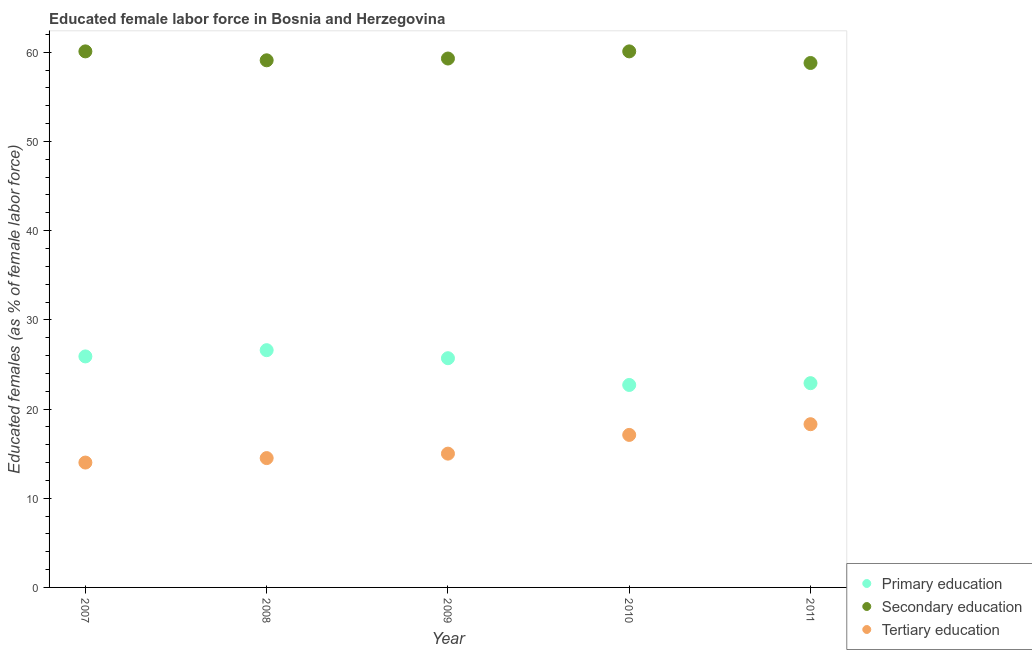What is the percentage of female labor force who received secondary education in 2007?
Provide a short and direct response. 60.1. Across all years, what is the maximum percentage of female labor force who received primary education?
Provide a short and direct response. 26.6. Across all years, what is the minimum percentage of female labor force who received primary education?
Provide a short and direct response. 22.7. In which year was the percentage of female labor force who received secondary education maximum?
Keep it short and to the point. 2007. In which year was the percentage of female labor force who received tertiary education minimum?
Ensure brevity in your answer.  2007. What is the total percentage of female labor force who received tertiary education in the graph?
Ensure brevity in your answer.  78.9. What is the difference between the percentage of female labor force who received secondary education in 2008 and that in 2009?
Your response must be concise. -0.2. What is the difference between the percentage of female labor force who received secondary education in 2010 and the percentage of female labor force who received primary education in 2009?
Give a very brief answer. 34.4. What is the average percentage of female labor force who received secondary education per year?
Offer a very short reply. 59.48. In the year 2007, what is the difference between the percentage of female labor force who received primary education and percentage of female labor force who received tertiary education?
Keep it short and to the point. 11.9. In how many years, is the percentage of female labor force who received primary education greater than 12 %?
Ensure brevity in your answer.  5. What is the ratio of the percentage of female labor force who received secondary education in 2007 to that in 2009?
Offer a very short reply. 1.01. Is the percentage of female labor force who received tertiary education in 2007 less than that in 2009?
Keep it short and to the point. Yes. Is the difference between the percentage of female labor force who received primary education in 2010 and 2011 greater than the difference between the percentage of female labor force who received tertiary education in 2010 and 2011?
Offer a very short reply. Yes. What is the difference between the highest and the second highest percentage of female labor force who received primary education?
Ensure brevity in your answer.  0.7. What is the difference between the highest and the lowest percentage of female labor force who received secondary education?
Offer a terse response. 1.3. In how many years, is the percentage of female labor force who received primary education greater than the average percentage of female labor force who received primary education taken over all years?
Offer a very short reply. 3. Is it the case that in every year, the sum of the percentage of female labor force who received primary education and percentage of female labor force who received secondary education is greater than the percentage of female labor force who received tertiary education?
Provide a short and direct response. Yes. Is the percentage of female labor force who received tertiary education strictly less than the percentage of female labor force who received primary education over the years?
Your answer should be compact. Yes. How many dotlines are there?
Provide a succinct answer. 3. Are the values on the major ticks of Y-axis written in scientific E-notation?
Your response must be concise. No. Does the graph contain grids?
Your answer should be very brief. No. Where does the legend appear in the graph?
Ensure brevity in your answer.  Bottom right. What is the title of the graph?
Your answer should be very brief. Educated female labor force in Bosnia and Herzegovina. What is the label or title of the X-axis?
Your answer should be compact. Year. What is the label or title of the Y-axis?
Make the answer very short. Educated females (as % of female labor force). What is the Educated females (as % of female labor force) of Primary education in 2007?
Provide a succinct answer. 25.9. What is the Educated females (as % of female labor force) in Secondary education in 2007?
Your response must be concise. 60.1. What is the Educated females (as % of female labor force) in Primary education in 2008?
Your response must be concise. 26.6. What is the Educated females (as % of female labor force) of Secondary education in 2008?
Your answer should be very brief. 59.1. What is the Educated females (as % of female labor force) in Tertiary education in 2008?
Provide a short and direct response. 14.5. What is the Educated females (as % of female labor force) of Primary education in 2009?
Provide a succinct answer. 25.7. What is the Educated females (as % of female labor force) in Secondary education in 2009?
Your answer should be compact. 59.3. What is the Educated females (as % of female labor force) of Tertiary education in 2009?
Provide a succinct answer. 15. What is the Educated females (as % of female labor force) of Primary education in 2010?
Your answer should be compact. 22.7. What is the Educated females (as % of female labor force) in Secondary education in 2010?
Offer a very short reply. 60.1. What is the Educated females (as % of female labor force) in Tertiary education in 2010?
Offer a very short reply. 17.1. What is the Educated females (as % of female labor force) in Primary education in 2011?
Your answer should be very brief. 22.9. What is the Educated females (as % of female labor force) of Secondary education in 2011?
Make the answer very short. 58.8. What is the Educated females (as % of female labor force) in Tertiary education in 2011?
Your response must be concise. 18.3. Across all years, what is the maximum Educated females (as % of female labor force) in Primary education?
Offer a terse response. 26.6. Across all years, what is the maximum Educated females (as % of female labor force) in Secondary education?
Your response must be concise. 60.1. Across all years, what is the maximum Educated females (as % of female labor force) of Tertiary education?
Give a very brief answer. 18.3. Across all years, what is the minimum Educated females (as % of female labor force) in Primary education?
Keep it short and to the point. 22.7. Across all years, what is the minimum Educated females (as % of female labor force) of Secondary education?
Provide a short and direct response. 58.8. Across all years, what is the minimum Educated females (as % of female labor force) of Tertiary education?
Your answer should be very brief. 14. What is the total Educated females (as % of female labor force) of Primary education in the graph?
Your answer should be compact. 123.8. What is the total Educated females (as % of female labor force) of Secondary education in the graph?
Give a very brief answer. 297.4. What is the total Educated females (as % of female labor force) of Tertiary education in the graph?
Provide a short and direct response. 78.9. What is the difference between the Educated females (as % of female labor force) in Secondary education in 2007 and that in 2008?
Offer a terse response. 1. What is the difference between the Educated females (as % of female labor force) of Primary education in 2007 and that in 2009?
Make the answer very short. 0.2. What is the difference between the Educated females (as % of female labor force) in Primary education in 2007 and that in 2010?
Give a very brief answer. 3.2. What is the difference between the Educated females (as % of female labor force) in Secondary education in 2007 and that in 2010?
Give a very brief answer. 0. What is the difference between the Educated females (as % of female labor force) of Tertiary education in 2007 and that in 2011?
Your response must be concise. -4.3. What is the difference between the Educated females (as % of female labor force) in Tertiary education in 2008 and that in 2009?
Offer a very short reply. -0.5. What is the difference between the Educated females (as % of female labor force) of Secondary education in 2008 and that in 2010?
Ensure brevity in your answer.  -1. What is the difference between the Educated females (as % of female labor force) in Primary education in 2009 and that in 2010?
Keep it short and to the point. 3. What is the difference between the Educated females (as % of female labor force) of Secondary education in 2009 and that in 2010?
Make the answer very short. -0.8. What is the difference between the Educated females (as % of female labor force) in Primary education in 2009 and that in 2011?
Your response must be concise. 2.8. What is the difference between the Educated females (as % of female labor force) of Secondary education in 2009 and that in 2011?
Offer a very short reply. 0.5. What is the difference between the Educated females (as % of female labor force) in Primary education in 2007 and the Educated females (as % of female labor force) in Secondary education in 2008?
Your response must be concise. -33.2. What is the difference between the Educated females (as % of female labor force) in Primary education in 2007 and the Educated females (as % of female labor force) in Tertiary education in 2008?
Your answer should be very brief. 11.4. What is the difference between the Educated females (as % of female labor force) in Secondary education in 2007 and the Educated females (as % of female labor force) in Tertiary education in 2008?
Offer a very short reply. 45.6. What is the difference between the Educated females (as % of female labor force) in Primary education in 2007 and the Educated females (as % of female labor force) in Secondary education in 2009?
Your answer should be very brief. -33.4. What is the difference between the Educated females (as % of female labor force) in Secondary education in 2007 and the Educated females (as % of female labor force) in Tertiary education in 2009?
Offer a terse response. 45.1. What is the difference between the Educated females (as % of female labor force) of Primary education in 2007 and the Educated females (as % of female labor force) of Secondary education in 2010?
Offer a very short reply. -34.2. What is the difference between the Educated females (as % of female labor force) of Primary education in 2007 and the Educated females (as % of female labor force) of Tertiary education in 2010?
Give a very brief answer. 8.8. What is the difference between the Educated females (as % of female labor force) of Secondary education in 2007 and the Educated females (as % of female labor force) of Tertiary education in 2010?
Give a very brief answer. 43. What is the difference between the Educated females (as % of female labor force) of Primary education in 2007 and the Educated females (as % of female labor force) of Secondary education in 2011?
Ensure brevity in your answer.  -32.9. What is the difference between the Educated females (as % of female labor force) of Primary education in 2007 and the Educated females (as % of female labor force) of Tertiary education in 2011?
Offer a very short reply. 7.6. What is the difference between the Educated females (as % of female labor force) in Secondary education in 2007 and the Educated females (as % of female labor force) in Tertiary education in 2011?
Your response must be concise. 41.8. What is the difference between the Educated females (as % of female labor force) of Primary education in 2008 and the Educated females (as % of female labor force) of Secondary education in 2009?
Keep it short and to the point. -32.7. What is the difference between the Educated females (as % of female labor force) of Secondary education in 2008 and the Educated females (as % of female labor force) of Tertiary education in 2009?
Your answer should be compact. 44.1. What is the difference between the Educated females (as % of female labor force) of Primary education in 2008 and the Educated females (as % of female labor force) of Secondary education in 2010?
Offer a very short reply. -33.5. What is the difference between the Educated females (as % of female labor force) of Primary education in 2008 and the Educated females (as % of female labor force) of Secondary education in 2011?
Offer a terse response. -32.2. What is the difference between the Educated females (as % of female labor force) of Secondary education in 2008 and the Educated females (as % of female labor force) of Tertiary education in 2011?
Make the answer very short. 40.8. What is the difference between the Educated females (as % of female labor force) in Primary education in 2009 and the Educated females (as % of female labor force) in Secondary education in 2010?
Ensure brevity in your answer.  -34.4. What is the difference between the Educated females (as % of female labor force) of Secondary education in 2009 and the Educated females (as % of female labor force) of Tertiary education in 2010?
Your response must be concise. 42.2. What is the difference between the Educated females (as % of female labor force) of Primary education in 2009 and the Educated females (as % of female labor force) of Secondary education in 2011?
Keep it short and to the point. -33.1. What is the difference between the Educated females (as % of female labor force) in Primary education in 2009 and the Educated females (as % of female labor force) in Tertiary education in 2011?
Ensure brevity in your answer.  7.4. What is the difference between the Educated females (as % of female labor force) of Secondary education in 2009 and the Educated females (as % of female labor force) of Tertiary education in 2011?
Give a very brief answer. 41. What is the difference between the Educated females (as % of female labor force) in Primary education in 2010 and the Educated females (as % of female labor force) in Secondary education in 2011?
Your response must be concise. -36.1. What is the difference between the Educated females (as % of female labor force) of Primary education in 2010 and the Educated females (as % of female labor force) of Tertiary education in 2011?
Make the answer very short. 4.4. What is the difference between the Educated females (as % of female labor force) in Secondary education in 2010 and the Educated females (as % of female labor force) in Tertiary education in 2011?
Make the answer very short. 41.8. What is the average Educated females (as % of female labor force) of Primary education per year?
Give a very brief answer. 24.76. What is the average Educated females (as % of female labor force) in Secondary education per year?
Offer a terse response. 59.48. What is the average Educated females (as % of female labor force) of Tertiary education per year?
Your response must be concise. 15.78. In the year 2007, what is the difference between the Educated females (as % of female labor force) of Primary education and Educated females (as % of female labor force) of Secondary education?
Make the answer very short. -34.2. In the year 2007, what is the difference between the Educated females (as % of female labor force) in Secondary education and Educated females (as % of female labor force) in Tertiary education?
Your answer should be compact. 46.1. In the year 2008, what is the difference between the Educated females (as % of female labor force) of Primary education and Educated females (as % of female labor force) of Secondary education?
Ensure brevity in your answer.  -32.5. In the year 2008, what is the difference between the Educated females (as % of female labor force) of Secondary education and Educated females (as % of female labor force) of Tertiary education?
Your response must be concise. 44.6. In the year 2009, what is the difference between the Educated females (as % of female labor force) of Primary education and Educated females (as % of female labor force) of Secondary education?
Your answer should be compact. -33.6. In the year 2009, what is the difference between the Educated females (as % of female labor force) of Primary education and Educated females (as % of female labor force) of Tertiary education?
Your answer should be compact. 10.7. In the year 2009, what is the difference between the Educated females (as % of female labor force) in Secondary education and Educated females (as % of female labor force) in Tertiary education?
Ensure brevity in your answer.  44.3. In the year 2010, what is the difference between the Educated females (as % of female labor force) of Primary education and Educated females (as % of female labor force) of Secondary education?
Provide a short and direct response. -37.4. In the year 2010, what is the difference between the Educated females (as % of female labor force) of Primary education and Educated females (as % of female labor force) of Tertiary education?
Your answer should be compact. 5.6. In the year 2010, what is the difference between the Educated females (as % of female labor force) of Secondary education and Educated females (as % of female labor force) of Tertiary education?
Offer a very short reply. 43. In the year 2011, what is the difference between the Educated females (as % of female labor force) of Primary education and Educated females (as % of female labor force) of Secondary education?
Your answer should be compact. -35.9. In the year 2011, what is the difference between the Educated females (as % of female labor force) in Primary education and Educated females (as % of female labor force) in Tertiary education?
Give a very brief answer. 4.6. In the year 2011, what is the difference between the Educated females (as % of female labor force) of Secondary education and Educated females (as % of female labor force) of Tertiary education?
Provide a short and direct response. 40.5. What is the ratio of the Educated females (as % of female labor force) in Primary education in 2007 to that in 2008?
Provide a succinct answer. 0.97. What is the ratio of the Educated females (as % of female labor force) in Secondary education in 2007 to that in 2008?
Offer a terse response. 1.02. What is the ratio of the Educated females (as % of female labor force) in Tertiary education in 2007 to that in 2008?
Offer a very short reply. 0.97. What is the ratio of the Educated females (as % of female labor force) of Secondary education in 2007 to that in 2009?
Your answer should be very brief. 1.01. What is the ratio of the Educated females (as % of female labor force) in Primary education in 2007 to that in 2010?
Your answer should be compact. 1.14. What is the ratio of the Educated females (as % of female labor force) of Secondary education in 2007 to that in 2010?
Keep it short and to the point. 1. What is the ratio of the Educated females (as % of female labor force) in Tertiary education in 2007 to that in 2010?
Your answer should be compact. 0.82. What is the ratio of the Educated females (as % of female labor force) of Primary education in 2007 to that in 2011?
Give a very brief answer. 1.13. What is the ratio of the Educated females (as % of female labor force) of Secondary education in 2007 to that in 2011?
Offer a terse response. 1.02. What is the ratio of the Educated females (as % of female labor force) of Tertiary education in 2007 to that in 2011?
Offer a very short reply. 0.77. What is the ratio of the Educated females (as % of female labor force) of Primary education in 2008 to that in 2009?
Your response must be concise. 1.03. What is the ratio of the Educated females (as % of female labor force) in Tertiary education in 2008 to that in 2009?
Make the answer very short. 0.97. What is the ratio of the Educated females (as % of female labor force) of Primary education in 2008 to that in 2010?
Keep it short and to the point. 1.17. What is the ratio of the Educated females (as % of female labor force) of Secondary education in 2008 to that in 2010?
Offer a very short reply. 0.98. What is the ratio of the Educated females (as % of female labor force) of Tertiary education in 2008 to that in 2010?
Your answer should be very brief. 0.85. What is the ratio of the Educated females (as % of female labor force) in Primary education in 2008 to that in 2011?
Offer a terse response. 1.16. What is the ratio of the Educated females (as % of female labor force) of Secondary education in 2008 to that in 2011?
Make the answer very short. 1.01. What is the ratio of the Educated females (as % of female labor force) in Tertiary education in 2008 to that in 2011?
Your response must be concise. 0.79. What is the ratio of the Educated females (as % of female labor force) of Primary education in 2009 to that in 2010?
Your answer should be compact. 1.13. What is the ratio of the Educated females (as % of female labor force) of Secondary education in 2009 to that in 2010?
Keep it short and to the point. 0.99. What is the ratio of the Educated females (as % of female labor force) in Tertiary education in 2009 to that in 2010?
Keep it short and to the point. 0.88. What is the ratio of the Educated females (as % of female labor force) of Primary education in 2009 to that in 2011?
Make the answer very short. 1.12. What is the ratio of the Educated females (as % of female labor force) of Secondary education in 2009 to that in 2011?
Give a very brief answer. 1.01. What is the ratio of the Educated females (as % of female labor force) in Tertiary education in 2009 to that in 2011?
Offer a very short reply. 0.82. What is the ratio of the Educated females (as % of female labor force) of Primary education in 2010 to that in 2011?
Your answer should be compact. 0.99. What is the ratio of the Educated females (as % of female labor force) in Secondary education in 2010 to that in 2011?
Your response must be concise. 1.02. What is the ratio of the Educated females (as % of female labor force) in Tertiary education in 2010 to that in 2011?
Keep it short and to the point. 0.93. What is the difference between the highest and the second highest Educated females (as % of female labor force) of Secondary education?
Provide a succinct answer. 0. What is the difference between the highest and the second highest Educated females (as % of female labor force) in Tertiary education?
Your response must be concise. 1.2. What is the difference between the highest and the lowest Educated females (as % of female labor force) in Primary education?
Ensure brevity in your answer.  3.9. 